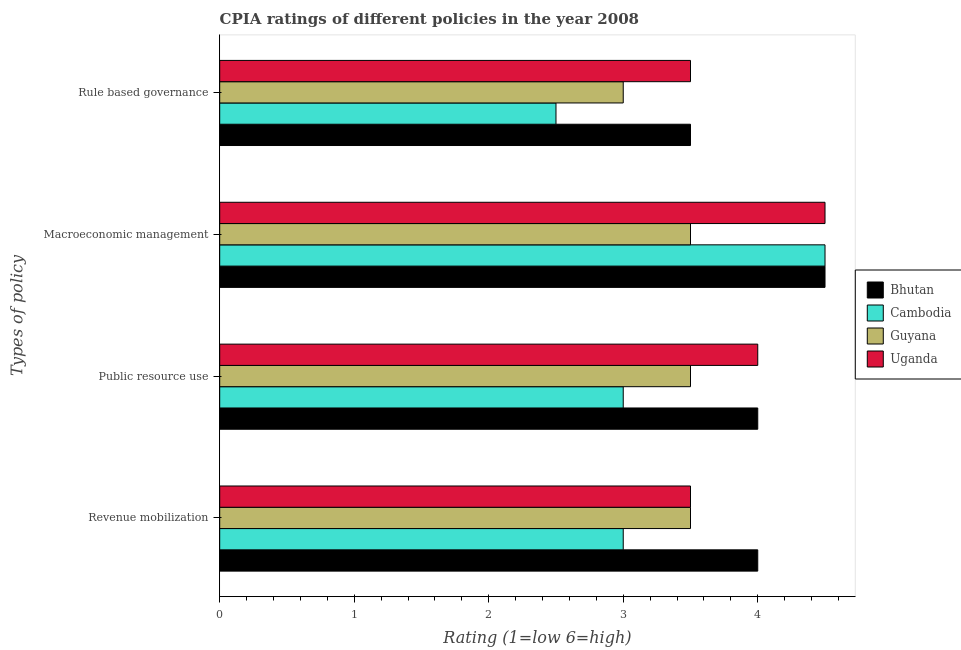How many groups of bars are there?
Ensure brevity in your answer.  4. Are the number of bars per tick equal to the number of legend labels?
Your answer should be compact. Yes. How many bars are there on the 3rd tick from the bottom?
Give a very brief answer. 4. What is the label of the 4th group of bars from the top?
Offer a very short reply. Revenue mobilization. Across all countries, what is the maximum cpia rating of public resource use?
Make the answer very short. 4. In which country was the cpia rating of public resource use maximum?
Make the answer very short. Bhutan. In which country was the cpia rating of revenue mobilization minimum?
Your answer should be compact. Cambodia. What is the total cpia rating of macroeconomic management in the graph?
Your response must be concise. 17. What is the difference between the cpia rating of revenue mobilization in Uganda and that in Cambodia?
Provide a short and direct response. 0.5. What is the difference between the cpia rating of public resource use in Bhutan and the cpia rating of revenue mobilization in Guyana?
Offer a very short reply. 0.5. What is the average cpia rating of revenue mobilization per country?
Keep it short and to the point. 3.5. In how many countries, is the cpia rating of macroeconomic management greater than 3.6 ?
Your answer should be very brief. 3. Is the cpia rating of revenue mobilization in Guyana less than that in Cambodia?
Provide a short and direct response. No. Is the difference between the cpia rating of macroeconomic management in Guyana and Bhutan greater than the difference between the cpia rating of revenue mobilization in Guyana and Bhutan?
Make the answer very short. No. What is the difference between the highest and the lowest cpia rating of macroeconomic management?
Give a very brief answer. 1. In how many countries, is the cpia rating of rule based governance greater than the average cpia rating of rule based governance taken over all countries?
Make the answer very short. 2. Is the sum of the cpia rating of public resource use in Cambodia and Guyana greater than the maximum cpia rating of macroeconomic management across all countries?
Offer a very short reply. Yes. Is it the case that in every country, the sum of the cpia rating of public resource use and cpia rating of revenue mobilization is greater than the sum of cpia rating of macroeconomic management and cpia rating of rule based governance?
Keep it short and to the point. No. What does the 2nd bar from the top in Revenue mobilization represents?
Ensure brevity in your answer.  Guyana. What does the 3rd bar from the bottom in Public resource use represents?
Offer a terse response. Guyana. How many bars are there?
Ensure brevity in your answer.  16. How many countries are there in the graph?
Provide a succinct answer. 4. What is the difference between two consecutive major ticks on the X-axis?
Provide a succinct answer. 1. Are the values on the major ticks of X-axis written in scientific E-notation?
Keep it short and to the point. No. Does the graph contain any zero values?
Ensure brevity in your answer.  No. Does the graph contain grids?
Your answer should be compact. No. What is the title of the graph?
Your response must be concise. CPIA ratings of different policies in the year 2008. What is the label or title of the X-axis?
Your answer should be very brief. Rating (1=low 6=high). What is the label or title of the Y-axis?
Your answer should be compact. Types of policy. What is the Rating (1=low 6=high) in Uganda in Revenue mobilization?
Offer a very short reply. 3.5. What is the Rating (1=low 6=high) of Bhutan in Public resource use?
Make the answer very short. 4. What is the Rating (1=low 6=high) of Cambodia in Public resource use?
Your response must be concise. 3. What is the Rating (1=low 6=high) in Guyana in Public resource use?
Provide a short and direct response. 3.5. What is the Rating (1=low 6=high) of Uganda in Public resource use?
Provide a succinct answer. 4. What is the Rating (1=low 6=high) of Bhutan in Macroeconomic management?
Your response must be concise. 4.5. What is the Rating (1=low 6=high) in Cambodia in Macroeconomic management?
Keep it short and to the point. 4.5. What is the Rating (1=low 6=high) in Guyana in Macroeconomic management?
Provide a succinct answer. 3.5. What is the Rating (1=low 6=high) in Cambodia in Rule based governance?
Offer a terse response. 2.5. What is the Rating (1=low 6=high) in Guyana in Rule based governance?
Your answer should be compact. 3. Across all Types of policy, what is the maximum Rating (1=low 6=high) of Bhutan?
Provide a succinct answer. 4.5. Across all Types of policy, what is the minimum Rating (1=low 6=high) in Cambodia?
Offer a terse response. 2.5. Across all Types of policy, what is the minimum Rating (1=low 6=high) of Guyana?
Give a very brief answer. 3. What is the total Rating (1=low 6=high) of Bhutan in the graph?
Make the answer very short. 16. What is the total Rating (1=low 6=high) in Cambodia in the graph?
Provide a short and direct response. 13. What is the total Rating (1=low 6=high) in Guyana in the graph?
Offer a terse response. 13.5. What is the difference between the Rating (1=low 6=high) in Cambodia in Revenue mobilization and that in Public resource use?
Provide a succinct answer. 0. What is the difference between the Rating (1=low 6=high) in Guyana in Revenue mobilization and that in Public resource use?
Provide a succinct answer. 0. What is the difference between the Rating (1=low 6=high) of Uganda in Revenue mobilization and that in Public resource use?
Offer a very short reply. -0.5. What is the difference between the Rating (1=low 6=high) in Cambodia in Revenue mobilization and that in Macroeconomic management?
Keep it short and to the point. -1.5. What is the difference between the Rating (1=low 6=high) of Guyana in Revenue mobilization and that in Macroeconomic management?
Your answer should be compact. 0. What is the difference between the Rating (1=low 6=high) of Uganda in Revenue mobilization and that in Macroeconomic management?
Provide a succinct answer. -1. What is the difference between the Rating (1=low 6=high) in Bhutan in Revenue mobilization and that in Rule based governance?
Keep it short and to the point. 0.5. What is the difference between the Rating (1=low 6=high) of Uganda in Revenue mobilization and that in Rule based governance?
Keep it short and to the point. 0. What is the difference between the Rating (1=low 6=high) of Bhutan in Public resource use and that in Macroeconomic management?
Offer a terse response. -0.5. What is the difference between the Rating (1=low 6=high) of Cambodia in Public resource use and that in Macroeconomic management?
Provide a succinct answer. -1.5. What is the difference between the Rating (1=low 6=high) in Uganda in Public resource use and that in Macroeconomic management?
Provide a succinct answer. -0.5. What is the difference between the Rating (1=low 6=high) in Bhutan in Public resource use and that in Rule based governance?
Keep it short and to the point. 0.5. What is the difference between the Rating (1=low 6=high) in Guyana in Public resource use and that in Rule based governance?
Offer a very short reply. 0.5. What is the difference between the Rating (1=low 6=high) in Uganda in Public resource use and that in Rule based governance?
Offer a very short reply. 0.5. What is the difference between the Rating (1=low 6=high) in Guyana in Macroeconomic management and that in Rule based governance?
Make the answer very short. 0.5. What is the difference between the Rating (1=low 6=high) of Bhutan in Revenue mobilization and the Rating (1=low 6=high) of Cambodia in Public resource use?
Offer a terse response. 1. What is the difference between the Rating (1=low 6=high) of Bhutan in Revenue mobilization and the Rating (1=low 6=high) of Guyana in Public resource use?
Provide a succinct answer. 0.5. What is the difference between the Rating (1=low 6=high) in Bhutan in Revenue mobilization and the Rating (1=low 6=high) in Uganda in Public resource use?
Offer a terse response. 0. What is the difference between the Rating (1=low 6=high) in Cambodia in Revenue mobilization and the Rating (1=low 6=high) in Guyana in Public resource use?
Make the answer very short. -0.5. What is the difference between the Rating (1=low 6=high) in Bhutan in Revenue mobilization and the Rating (1=low 6=high) in Uganda in Macroeconomic management?
Your answer should be compact. -0.5. What is the difference between the Rating (1=low 6=high) of Cambodia in Revenue mobilization and the Rating (1=low 6=high) of Uganda in Macroeconomic management?
Provide a short and direct response. -1.5. What is the difference between the Rating (1=low 6=high) of Bhutan in Revenue mobilization and the Rating (1=low 6=high) of Uganda in Rule based governance?
Provide a succinct answer. 0.5. What is the difference between the Rating (1=low 6=high) of Cambodia in Revenue mobilization and the Rating (1=low 6=high) of Guyana in Rule based governance?
Provide a succinct answer. 0. What is the difference between the Rating (1=low 6=high) of Guyana in Revenue mobilization and the Rating (1=low 6=high) of Uganda in Rule based governance?
Your answer should be compact. 0. What is the difference between the Rating (1=low 6=high) of Bhutan in Public resource use and the Rating (1=low 6=high) of Guyana in Macroeconomic management?
Your response must be concise. 0.5. What is the difference between the Rating (1=low 6=high) in Bhutan in Public resource use and the Rating (1=low 6=high) in Guyana in Rule based governance?
Your answer should be very brief. 1. What is the difference between the Rating (1=low 6=high) of Bhutan in Public resource use and the Rating (1=low 6=high) of Uganda in Rule based governance?
Ensure brevity in your answer.  0.5. What is the difference between the Rating (1=low 6=high) in Cambodia in Public resource use and the Rating (1=low 6=high) in Uganda in Rule based governance?
Your response must be concise. -0.5. What is the difference between the Rating (1=low 6=high) of Guyana in Public resource use and the Rating (1=low 6=high) of Uganda in Rule based governance?
Your answer should be compact. 0. What is the difference between the Rating (1=low 6=high) of Bhutan in Macroeconomic management and the Rating (1=low 6=high) of Uganda in Rule based governance?
Your response must be concise. 1. What is the difference between the Rating (1=low 6=high) in Cambodia in Macroeconomic management and the Rating (1=low 6=high) in Uganda in Rule based governance?
Your answer should be compact. 1. What is the average Rating (1=low 6=high) of Bhutan per Types of policy?
Your answer should be compact. 4. What is the average Rating (1=low 6=high) in Guyana per Types of policy?
Keep it short and to the point. 3.38. What is the average Rating (1=low 6=high) in Uganda per Types of policy?
Provide a succinct answer. 3.88. What is the difference between the Rating (1=low 6=high) in Bhutan and Rating (1=low 6=high) in Uganda in Revenue mobilization?
Make the answer very short. 0.5. What is the difference between the Rating (1=low 6=high) of Cambodia and Rating (1=low 6=high) of Guyana in Revenue mobilization?
Keep it short and to the point. -0.5. What is the difference between the Rating (1=low 6=high) in Cambodia and Rating (1=low 6=high) in Uganda in Revenue mobilization?
Make the answer very short. -0.5. What is the difference between the Rating (1=low 6=high) in Guyana and Rating (1=low 6=high) in Uganda in Revenue mobilization?
Offer a terse response. 0. What is the difference between the Rating (1=low 6=high) in Bhutan and Rating (1=low 6=high) in Cambodia in Public resource use?
Make the answer very short. 1. What is the difference between the Rating (1=low 6=high) in Bhutan and Rating (1=low 6=high) in Guyana in Public resource use?
Keep it short and to the point. 0.5. What is the difference between the Rating (1=low 6=high) in Cambodia and Rating (1=low 6=high) in Guyana in Public resource use?
Provide a short and direct response. -0.5. What is the difference between the Rating (1=low 6=high) of Cambodia and Rating (1=low 6=high) of Guyana in Macroeconomic management?
Provide a succinct answer. 1. What is the difference between the Rating (1=low 6=high) in Bhutan and Rating (1=low 6=high) in Guyana in Rule based governance?
Give a very brief answer. 0.5. What is the difference between the Rating (1=low 6=high) of Bhutan and Rating (1=low 6=high) of Uganda in Rule based governance?
Offer a very short reply. 0. What is the difference between the Rating (1=low 6=high) of Cambodia and Rating (1=low 6=high) of Guyana in Rule based governance?
Provide a short and direct response. -0.5. What is the difference between the Rating (1=low 6=high) in Guyana and Rating (1=low 6=high) in Uganda in Rule based governance?
Provide a succinct answer. -0.5. What is the ratio of the Rating (1=low 6=high) in Bhutan in Revenue mobilization to that in Public resource use?
Provide a succinct answer. 1. What is the ratio of the Rating (1=low 6=high) in Cambodia in Revenue mobilization to that in Public resource use?
Provide a succinct answer. 1. What is the ratio of the Rating (1=low 6=high) in Guyana in Revenue mobilization to that in Public resource use?
Keep it short and to the point. 1. What is the ratio of the Rating (1=low 6=high) of Cambodia in Revenue mobilization to that in Macroeconomic management?
Provide a short and direct response. 0.67. What is the ratio of the Rating (1=low 6=high) of Guyana in Revenue mobilization to that in Rule based governance?
Your response must be concise. 1.17. What is the ratio of the Rating (1=low 6=high) in Uganda in Public resource use to that in Macroeconomic management?
Provide a succinct answer. 0.89. What is the ratio of the Rating (1=low 6=high) of Cambodia in Public resource use to that in Rule based governance?
Provide a short and direct response. 1.2. What is the ratio of the Rating (1=low 6=high) in Guyana in Public resource use to that in Rule based governance?
Give a very brief answer. 1.17. What is the ratio of the Rating (1=low 6=high) in Uganda in Public resource use to that in Rule based governance?
Keep it short and to the point. 1.14. What is the ratio of the Rating (1=low 6=high) of Cambodia in Macroeconomic management to that in Rule based governance?
Provide a succinct answer. 1.8. What is the ratio of the Rating (1=low 6=high) of Uganda in Macroeconomic management to that in Rule based governance?
Offer a terse response. 1.29. What is the difference between the highest and the second highest Rating (1=low 6=high) of Bhutan?
Provide a succinct answer. 0.5. What is the difference between the highest and the second highest Rating (1=low 6=high) in Cambodia?
Make the answer very short. 1.5. What is the difference between the highest and the lowest Rating (1=low 6=high) in Bhutan?
Offer a terse response. 1. What is the difference between the highest and the lowest Rating (1=low 6=high) of Guyana?
Make the answer very short. 0.5. What is the difference between the highest and the lowest Rating (1=low 6=high) of Uganda?
Your answer should be compact. 1. 